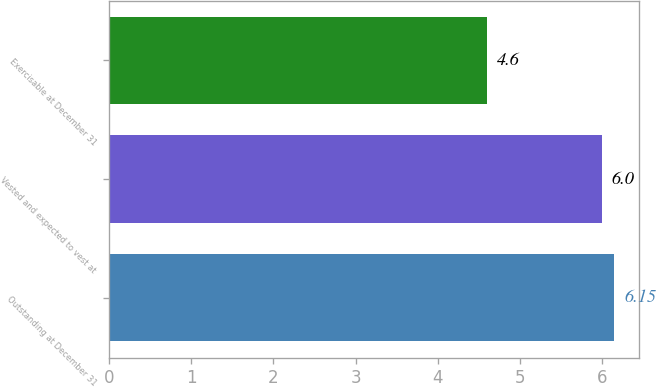Convert chart to OTSL. <chart><loc_0><loc_0><loc_500><loc_500><bar_chart><fcel>Outstanding at December 31<fcel>Vested and expected to vest at<fcel>Exercisable at December 31<nl><fcel>6.15<fcel>6<fcel>4.6<nl></chart> 